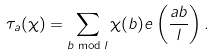<formula> <loc_0><loc_0><loc_500><loc_500>\tau _ { a } ( \chi ) = \sum _ { b \bmod { l } } \chi ( b ) e \left ( \frac { a b } { l } \right ) .</formula> 